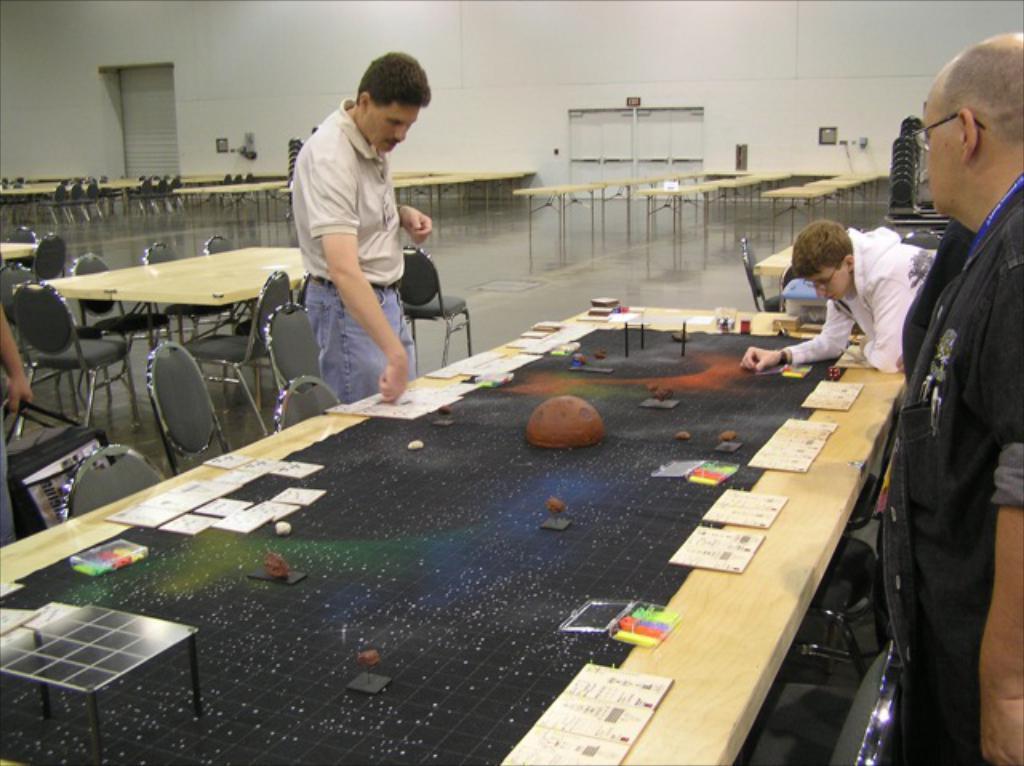How would you summarize this image in a sentence or two? In this picture we can see three men standing and playing on table with cards, boxes on it and in background we can see wall, door, tables, chair, shutter. 